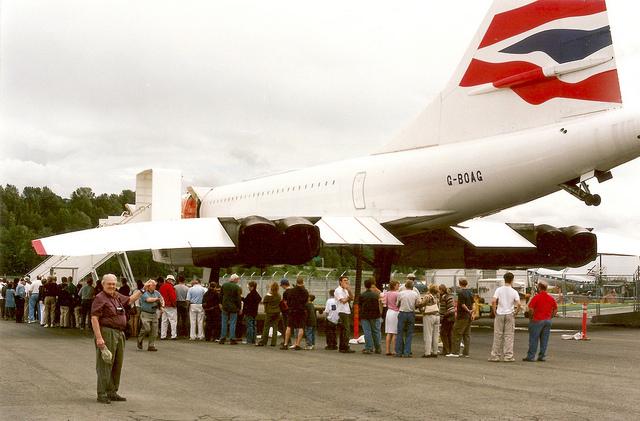How many planes are there?
Concise answer only. 1. Where is the plane?
Give a very brief answer. Airport. Is the plane in the sky?
Keep it brief. No. Why are all the people looking at the plane?
Give a very brief answer. On exhibit. 